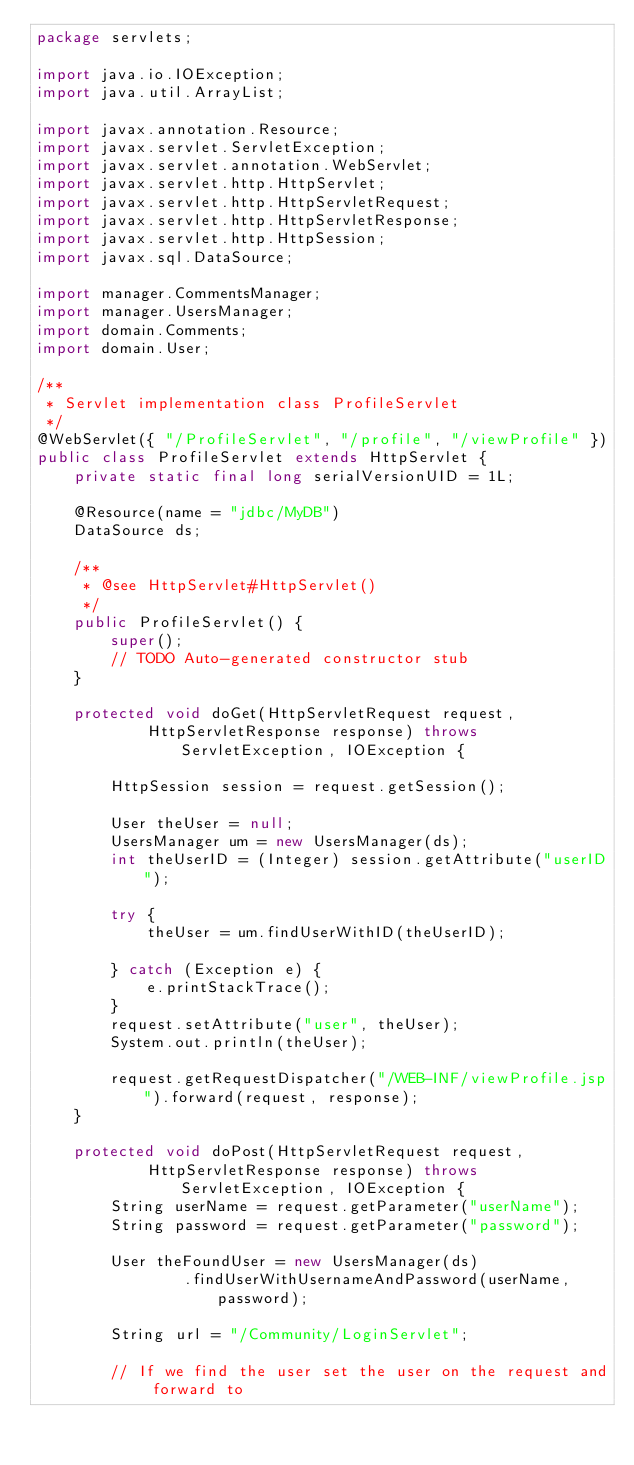<code> <loc_0><loc_0><loc_500><loc_500><_Java_>package servlets;

import java.io.IOException;
import java.util.ArrayList;

import javax.annotation.Resource;
import javax.servlet.ServletException;
import javax.servlet.annotation.WebServlet;
import javax.servlet.http.HttpServlet;
import javax.servlet.http.HttpServletRequest;
import javax.servlet.http.HttpServletResponse;
import javax.servlet.http.HttpSession;
import javax.sql.DataSource;

import manager.CommentsManager;
import manager.UsersManager;
import domain.Comments;
import domain.User;

/**
 * Servlet implementation class ProfileServlet
 */
@WebServlet({ "/ProfileServlet", "/profile", "/viewProfile" })
public class ProfileServlet extends HttpServlet {
	private static final long serialVersionUID = 1L;

	@Resource(name = "jdbc/MyDB")
	DataSource ds;

	/**
	 * @see HttpServlet#HttpServlet()
	 */
	public ProfileServlet() {
		super();
		// TODO Auto-generated constructor stub
	}

	protected void doGet(HttpServletRequest request,
			HttpServletResponse response) throws ServletException, IOException {

		HttpSession session = request.getSession();

		User theUser = null;
		UsersManager um = new UsersManager(ds);
		int theUserID = (Integer) session.getAttribute("userID");
		
		try {
			theUser = um.findUserWithID(theUserID);

		} catch (Exception e) {
			e.printStackTrace();
		}
		request.setAttribute("user", theUser);
		System.out.println(theUser);
		
		request.getRequestDispatcher("/WEB-INF/viewProfile.jsp").forward(request, response);
	}

	protected void doPost(HttpServletRequest request,
			HttpServletResponse response) throws ServletException, IOException {
		String userName = request.getParameter("userName");
		String password = request.getParameter("password");

		User theFoundUser = new UsersManager(ds)
				.findUserWithUsernameAndPassword(userName, password);

		String url = "/Community/LoginServlet";

		// If we find the user set the user on the request and forward to</code> 